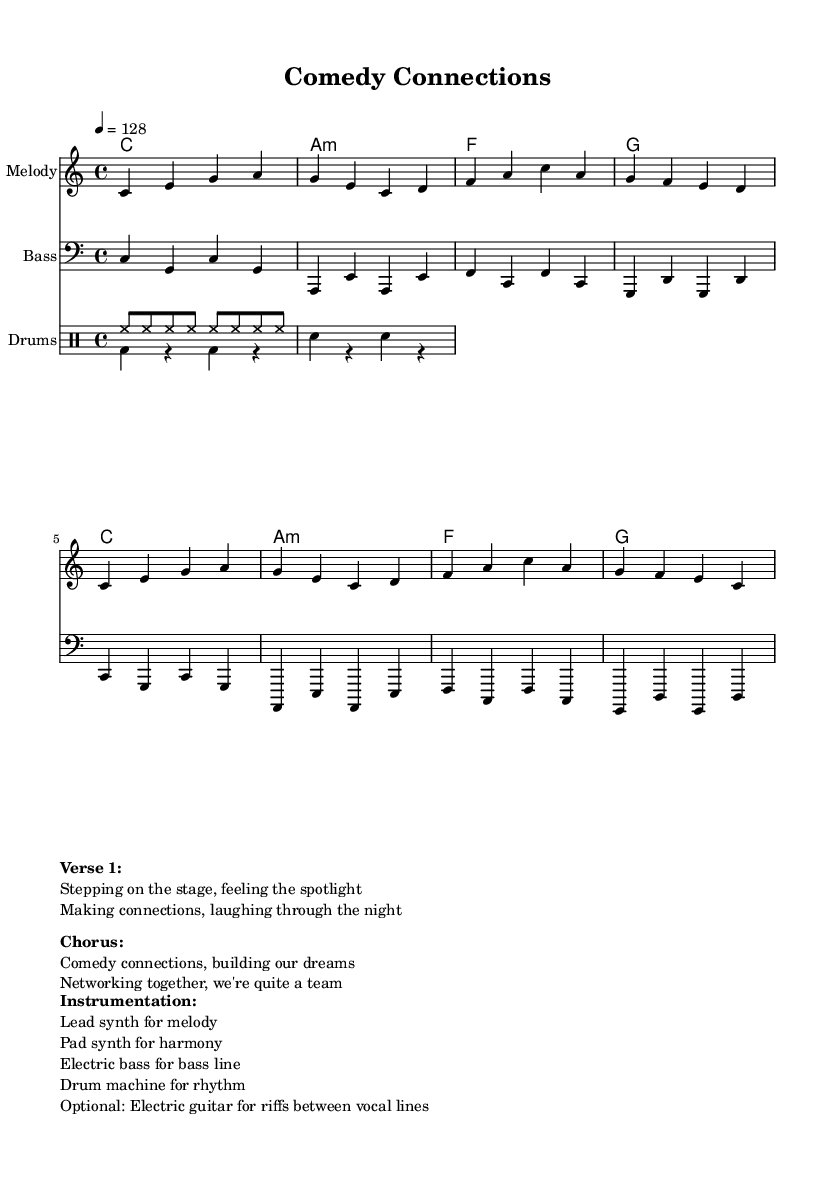What is the time signature of this music? The time signature is indicated in the music as "4/4", meaning there are four beats in each measure and the quarter note gets one beat.
Answer: 4/4 What is the tempo marking for this piece? The tempo marking is found in the global settings where it specifies "4 = 128", indicating that there are 128 beats per minute.
Answer: 128 What is the first note of the melody? The melody begins with the note "C" in the first measure, following the defined relative pitch from the "melody" section.
Answer: C How many measures are there in the melody? Counting the melody, it consists of 8 measures, as indicated by the bars in the notation provided.
Answer: 8 What instrument is predominantly used for the melody? The instrumentation specifies a "Lead synth" for the melody, which plays the primary melodic line throughout the piece.
Answer: Lead synth What type of rhythm pattern is used in the drum section? The drum pattern in the section consists of a "drum machine for rhythm," which typically implies a consistent electronic beat across the measures outlined for drums.
Answer: Drum machine What is the main theme depicted in the lyrics? The lyrics collectively focus on "Comedy connections," emphasizing the importance of networking and team building within the comedy industry.
Answer: Comedy connections 